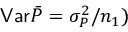Convert formula to latex. <formula><loc_0><loc_0><loc_500><loc_500>V a r \bar { P } = \sigma _ { P } ^ { 2 } / n _ { 1 } )</formula> 